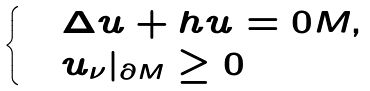<formula> <loc_0><loc_0><loc_500><loc_500>\begin{cases} & \Delta u + h u = 0 M , \\ & u _ { \nu } | _ { \partial M } \geq 0 \end{cases}</formula> 